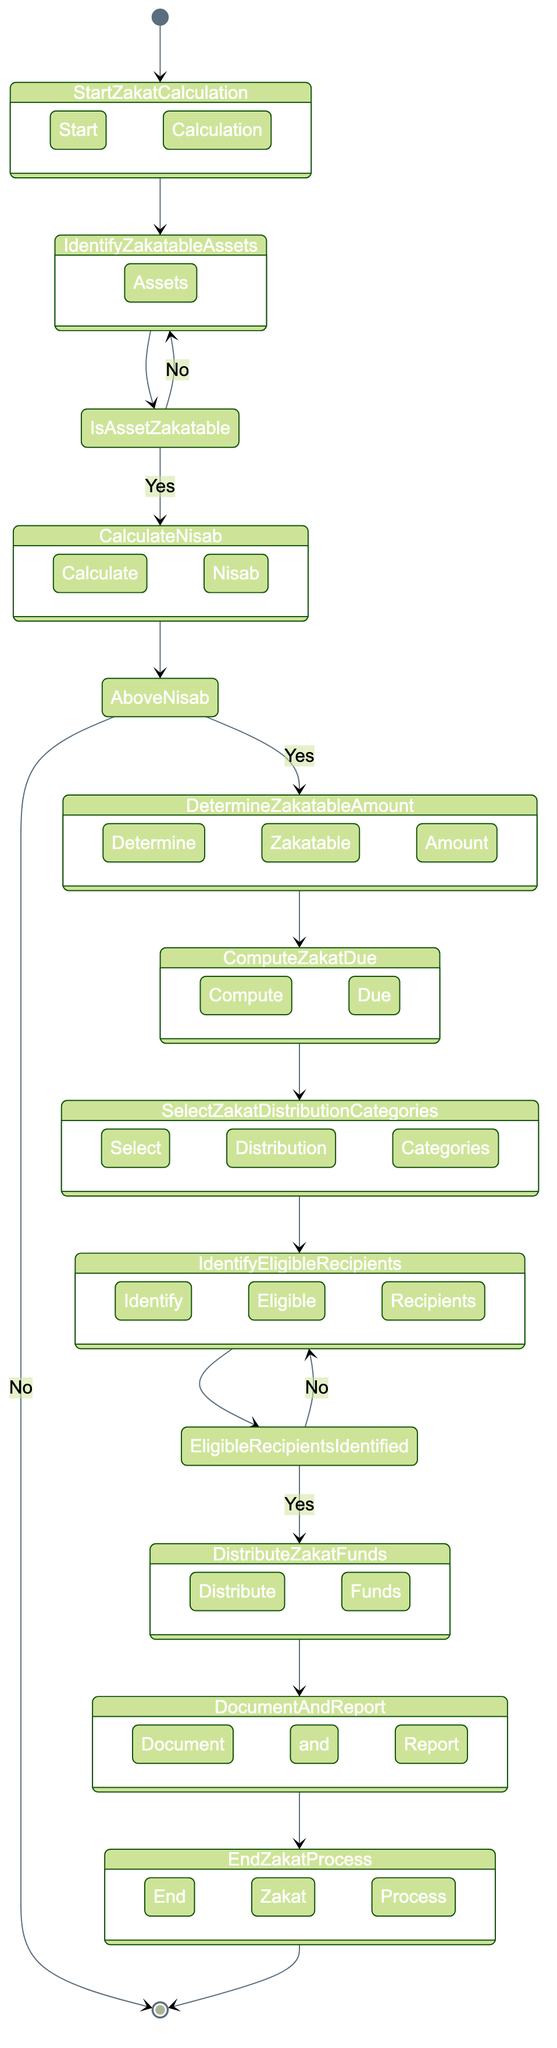What is the starting point of the Zakat process? The starting point of the Zakat process in the diagram is labeled as "Start Zakat Calculation." This serves as the initial point from which all activities commence.
Answer: Start Zakat Calculation How many decision points are there in the diagram? Upon examining the diagram, three decision points can be identified: "Is Asset Zakatable?", "Above Nisab?", and "Eligible Recipients Identified?" Counting these gives us a total of three decision points.
Answer: 3 What activity follows "Compute Zakat Due"? Following the "Compute Zakat Due" activity in the diagram is the "Select Zakat Distribution Categories" node, which indicates the next step in the process after computing the due amount.
Answer: Select Zakat Distribution Categories What is the consequence if the total asset value is below Nisab? If the total asset value is below the Nisab threshold, the diagram shows that the process will lead to an end point, meaning Zakat is not applicable in this scenario, and the workflow terminates.
Answer: End Zakat Process What action is taken if eligible recipients are not identified? If eligible recipients are not identified, the diagram indicates a return to "Identify Eligible Recipients," where further attempts will be made to find suitable recipients for Zakat distribution.
Answer: Identify Eligible Recipients What happens after distributing Zakat funds? After distributing Zakat funds, the next action as shown in the diagram is "Document and Report," where all transactions related to Zakat distribution are recorded for transparency.
Answer: Document and Report What is the minimum percentage applied to calculate Zakat due? The typical Zakat rate applied to calculate the Zakat due is 2.5%, as indicated during the "Compute Zakat Due" activity in the workflow.
Answer: 2.5% What is the final step in this Zakat calculation workflow? According to the diagram, the final step is labeled "End Zakat Process," marking the conclusion of the entire Zakat calculation and distribution workflow.
Answer: End Zakat Process 